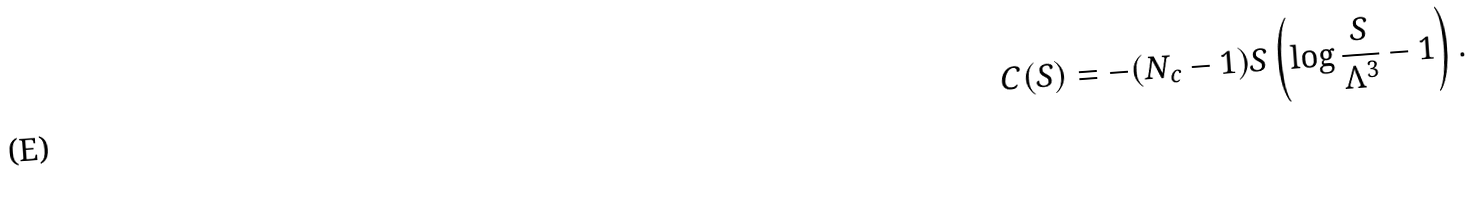<formula> <loc_0><loc_0><loc_500><loc_500>C ( S ) = - ( N _ { c } - 1 ) S \left ( \log { \frac { S } { \Lambda ^ { 3 } } } - 1 \right ) .</formula> 